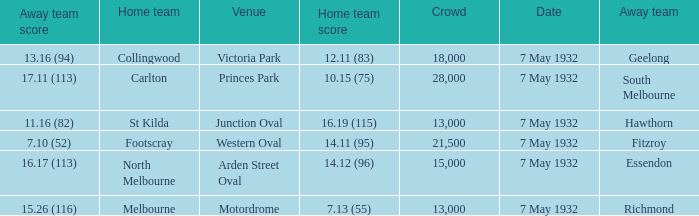What is the away team with a Crowd greater than 13,000, and a Home team score of 12.11 (83)? Geelong. 